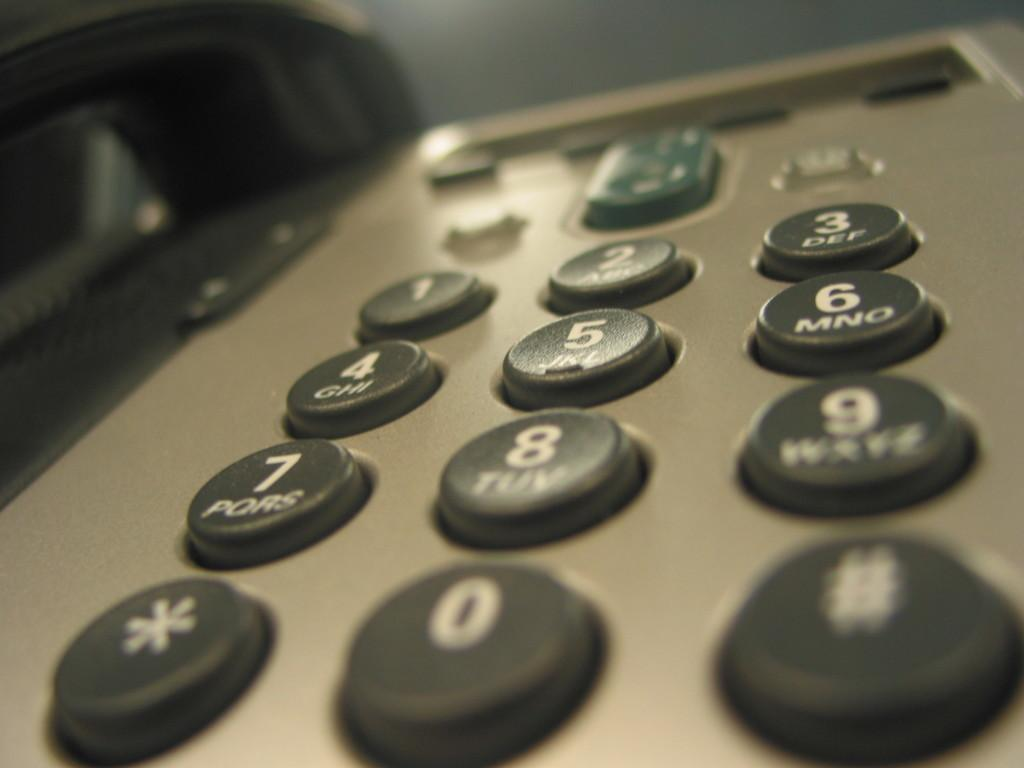<image>
Render a clear and concise summary of the photo. A silver telephone with black buttons has a green button above the button with a 2 on it. 